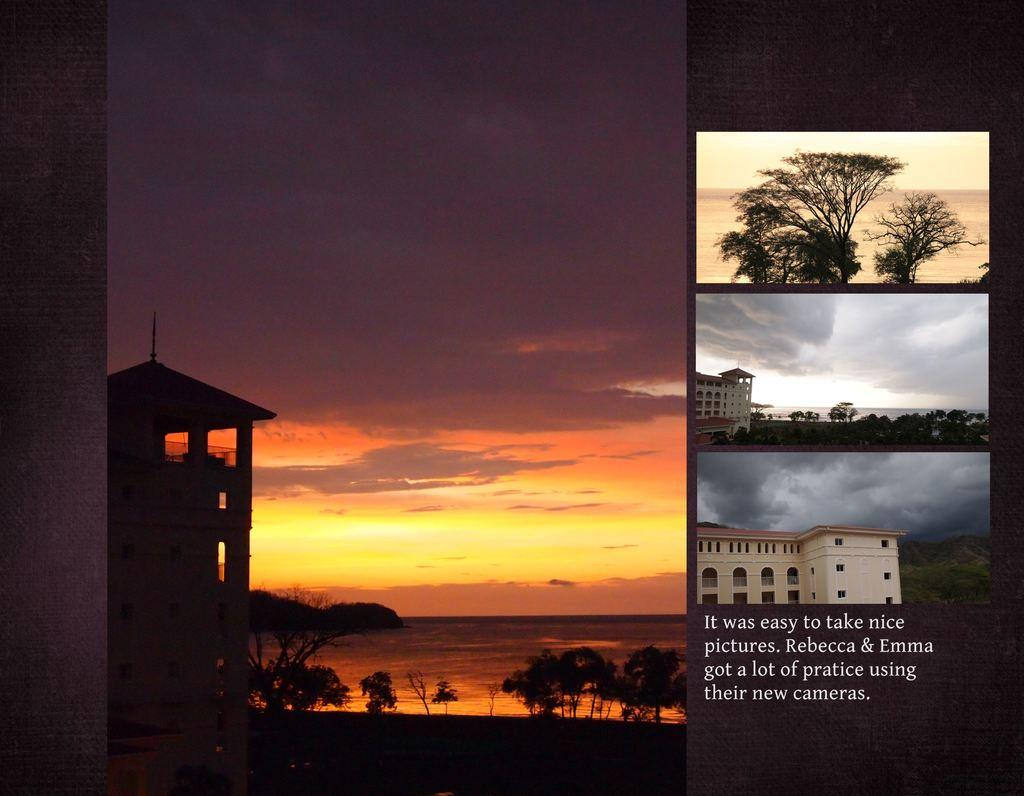What type of picture is in the image? The image contains a collage picture. What structures can be seen in the collage? There are buildings in the image. What type of natural elements are present in the collage? There are trees in the image. What part of the natural environment is visible in the collage? The sky is visible in the image. What additional element is present in the collage? There is text written on a poster in the image. Can you tell me how many trails are visible in the image? There are no trails present in the image; it contains a collage picture with buildings, trees, the sky, and text on a poster. What type of root system can be seen supporting the trees in the image? There is no root system visible in the image, as it is a collage picture with buildings, trees, the sky, and text on a poster. 